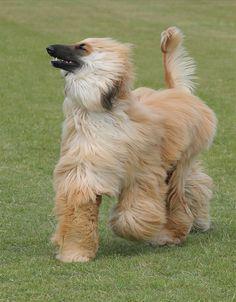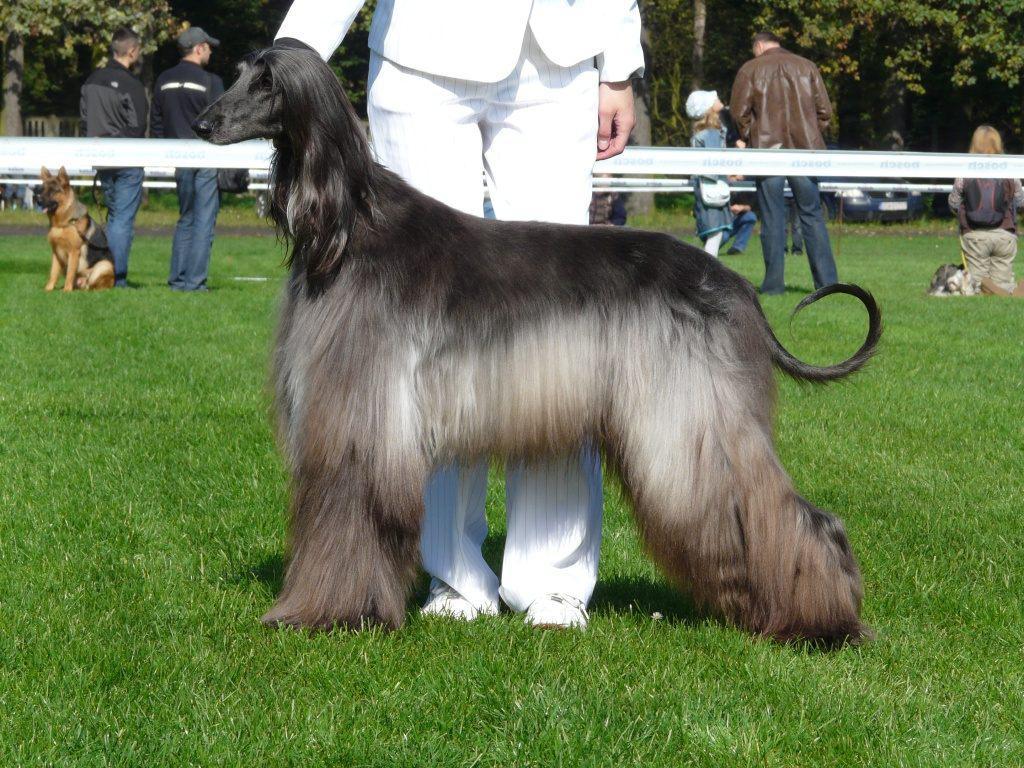The first image is the image on the left, the second image is the image on the right. For the images displayed, is the sentence "The dog in the image on the right is turned toward the right." factually correct? Answer yes or no. No. 